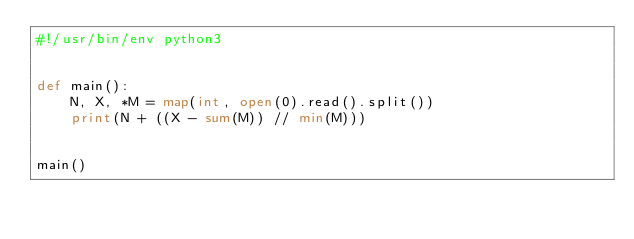Convert code to text. <code><loc_0><loc_0><loc_500><loc_500><_Python_>#!/usr/bin/env python3


def main():
    N, X, *M = map(int, open(0).read().split())
    print(N + ((X - sum(M)) // min(M)))


main()
</code> 